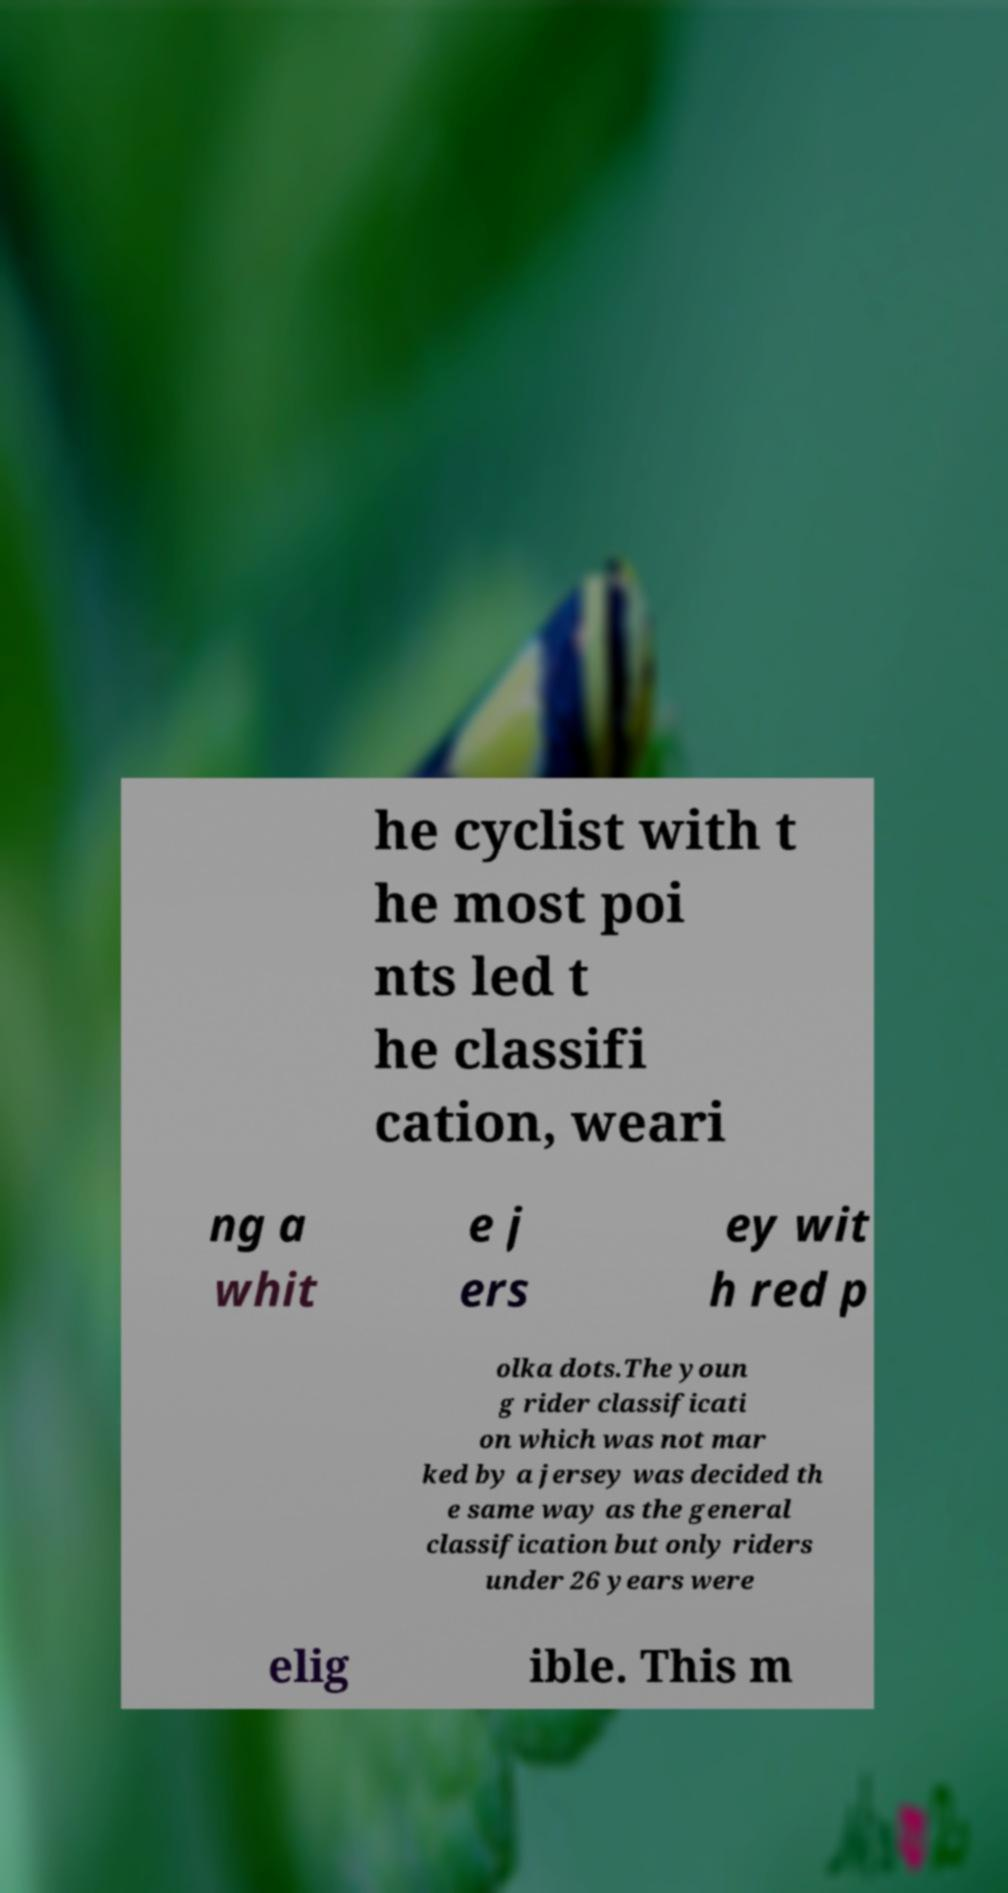Please read and relay the text visible in this image. What does it say? he cyclist with t he most poi nts led t he classifi cation, weari ng a whit e j ers ey wit h red p olka dots.The youn g rider classificati on which was not mar ked by a jersey was decided th e same way as the general classification but only riders under 26 years were elig ible. This m 